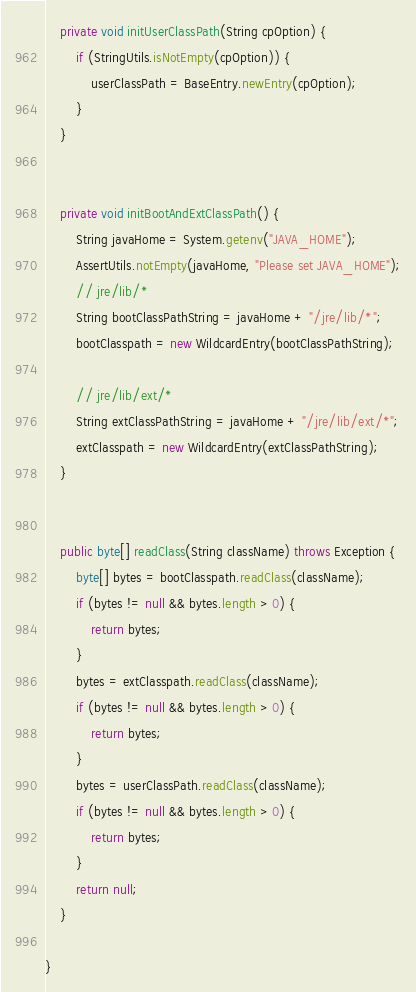<code> <loc_0><loc_0><loc_500><loc_500><_Java_>
    private void initUserClassPath(String cpOption) {
        if (StringUtils.isNotEmpty(cpOption)) {
            userClassPath = BaseEntry.newEntry(cpOption);
        }
    }


    private void initBootAndExtClassPath() {
        String javaHome = System.getenv("JAVA_HOME");
        AssertUtils.notEmpty(javaHome, "Please set JAVA_HOME");
        // jre/lib/*
        String bootClassPathString = javaHome + "/jre/lib/*";
        bootClasspath = new WildcardEntry(bootClassPathString);

        // jre/lib/ext/*
        String extClassPathString = javaHome + "/jre/lib/ext/*";
        extClasspath = new WildcardEntry(extClassPathString);
    }


    public byte[] readClass(String className) throws Exception {
        byte[] bytes = bootClasspath.readClass(className);
        if (bytes != null && bytes.length > 0) {
            return bytes;
        }
        bytes = extClasspath.readClass(className);
        if (bytes != null && bytes.length > 0) {
            return bytes;
        }
        bytes = userClassPath.readClass(className);
        if (bytes != null && bytes.length > 0) {
            return bytes;
        }
        return null;
    }

}
</code> 